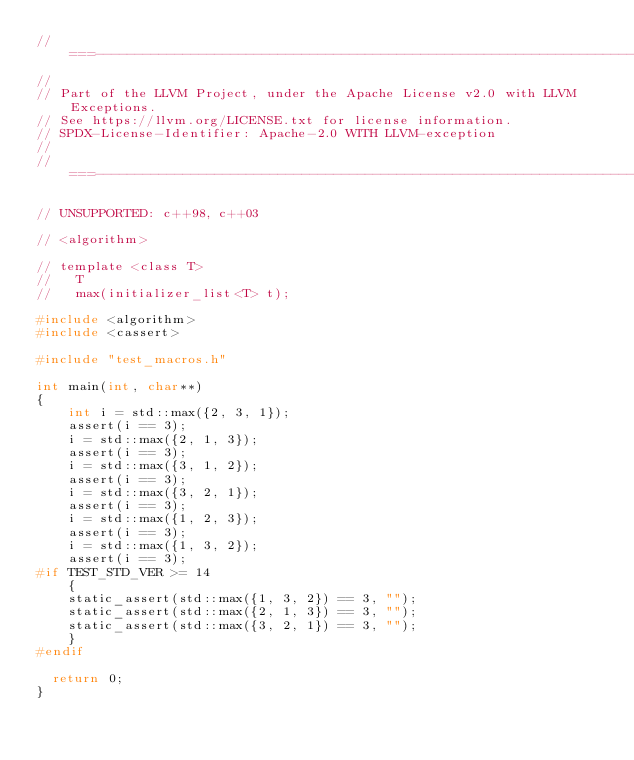Convert code to text. <code><loc_0><loc_0><loc_500><loc_500><_C++_>//===----------------------------------------------------------------------===//
//
// Part of the LLVM Project, under the Apache License v2.0 with LLVM Exceptions.
// See https://llvm.org/LICENSE.txt for license information.
// SPDX-License-Identifier: Apache-2.0 WITH LLVM-exception
//
//===----------------------------------------------------------------------===//

// UNSUPPORTED: c++98, c++03

// <algorithm>

// template <class T>
//   T
//   max(initializer_list<T> t);

#include <algorithm>
#include <cassert>

#include "test_macros.h"

int main(int, char**)
{
    int i = std::max({2, 3, 1});
    assert(i == 3);
    i = std::max({2, 1, 3});
    assert(i == 3);
    i = std::max({3, 1, 2});
    assert(i == 3);
    i = std::max({3, 2, 1});
    assert(i == 3);
    i = std::max({1, 2, 3});
    assert(i == 3);
    i = std::max({1, 3, 2});
    assert(i == 3);
#if TEST_STD_VER >= 14
    {
    static_assert(std::max({1, 3, 2}) == 3, "");
    static_assert(std::max({2, 1, 3}) == 3, "");
    static_assert(std::max({3, 2, 1}) == 3, "");
    }
#endif

  return 0;
}
</code> 